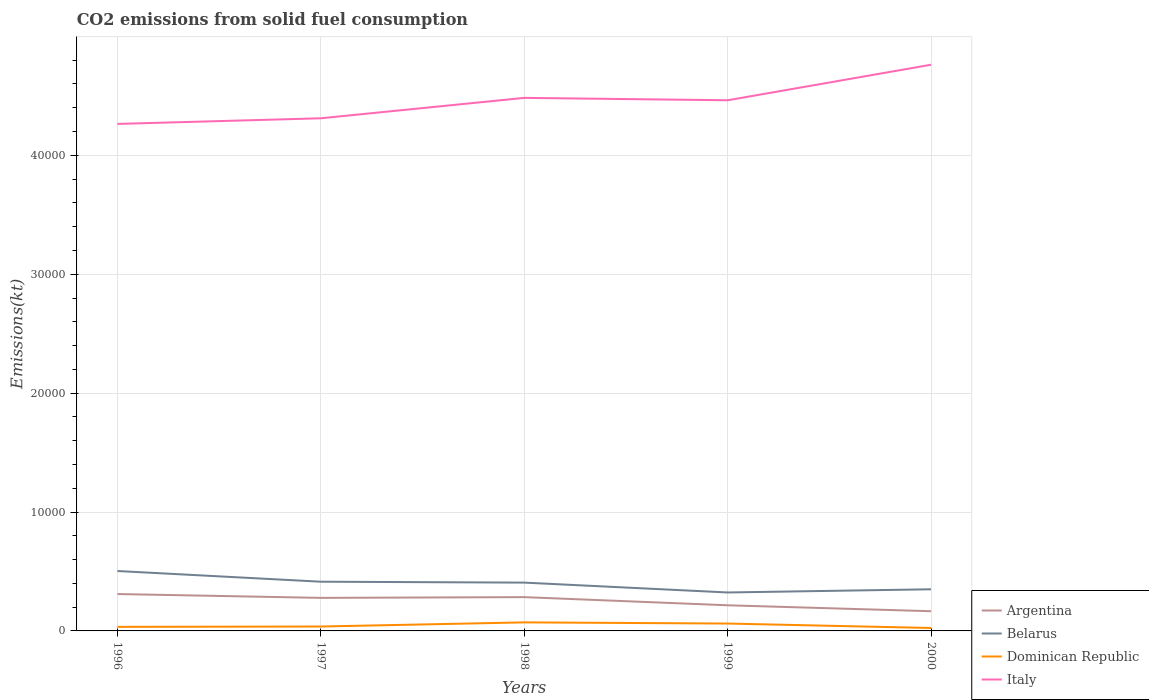Across all years, what is the maximum amount of CO2 emitted in Argentina?
Provide a succinct answer. 1657.48. What is the total amount of CO2 emitted in Belarus in the graph?
Offer a terse response. 898.41. What is the difference between the highest and the second highest amount of CO2 emitted in Dominican Republic?
Ensure brevity in your answer.  473.04. What is the difference between the highest and the lowest amount of CO2 emitted in Argentina?
Provide a short and direct response. 3. How many lines are there?
Provide a succinct answer. 4. How many years are there in the graph?
Make the answer very short. 5. Does the graph contain any zero values?
Your answer should be compact. No. How many legend labels are there?
Offer a very short reply. 4. How are the legend labels stacked?
Offer a terse response. Vertical. What is the title of the graph?
Offer a terse response. CO2 emissions from solid fuel consumption. What is the label or title of the Y-axis?
Provide a short and direct response. Emissions(kt). What is the Emissions(kt) of Argentina in 1996?
Give a very brief answer. 3102.28. What is the Emissions(kt) of Belarus in 1996?
Provide a short and direct response. 5038.46. What is the Emissions(kt) in Dominican Republic in 1996?
Give a very brief answer. 341.03. What is the Emissions(kt) of Italy in 1996?
Ensure brevity in your answer.  4.26e+04. What is the Emissions(kt) in Argentina in 1997?
Give a very brief answer. 2779.59. What is the Emissions(kt) in Belarus in 1997?
Provide a succinct answer. 4140.04. What is the Emissions(kt) of Dominican Republic in 1997?
Give a very brief answer. 370.37. What is the Emissions(kt) of Italy in 1997?
Ensure brevity in your answer.  4.31e+04. What is the Emissions(kt) of Argentina in 1998?
Your response must be concise. 2841.93. What is the Emissions(kt) of Belarus in 1998?
Your response must be concise. 4063.04. What is the Emissions(kt) in Dominican Republic in 1998?
Provide a short and direct response. 718.73. What is the Emissions(kt) in Italy in 1998?
Your answer should be compact. 4.48e+04. What is the Emissions(kt) in Argentina in 1999?
Make the answer very short. 2156.2. What is the Emissions(kt) of Belarus in 1999?
Provide a succinct answer. 3234.29. What is the Emissions(kt) of Dominican Republic in 1999?
Make the answer very short. 619.72. What is the Emissions(kt) in Italy in 1999?
Your response must be concise. 4.46e+04. What is the Emissions(kt) of Argentina in 2000?
Ensure brevity in your answer.  1657.48. What is the Emissions(kt) in Belarus in 2000?
Give a very brief answer. 3501.99. What is the Emissions(kt) of Dominican Republic in 2000?
Keep it short and to the point. 245.69. What is the Emissions(kt) of Italy in 2000?
Your response must be concise. 4.76e+04. Across all years, what is the maximum Emissions(kt) in Argentina?
Ensure brevity in your answer.  3102.28. Across all years, what is the maximum Emissions(kt) in Belarus?
Ensure brevity in your answer.  5038.46. Across all years, what is the maximum Emissions(kt) of Dominican Republic?
Ensure brevity in your answer.  718.73. Across all years, what is the maximum Emissions(kt) of Italy?
Your response must be concise. 4.76e+04. Across all years, what is the minimum Emissions(kt) in Argentina?
Make the answer very short. 1657.48. Across all years, what is the minimum Emissions(kt) in Belarus?
Ensure brevity in your answer.  3234.29. Across all years, what is the minimum Emissions(kt) in Dominican Republic?
Give a very brief answer. 245.69. Across all years, what is the minimum Emissions(kt) in Italy?
Your answer should be compact. 4.26e+04. What is the total Emissions(kt) in Argentina in the graph?
Provide a succinct answer. 1.25e+04. What is the total Emissions(kt) in Belarus in the graph?
Give a very brief answer. 2.00e+04. What is the total Emissions(kt) of Dominican Republic in the graph?
Keep it short and to the point. 2295.54. What is the total Emissions(kt) of Italy in the graph?
Give a very brief answer. 2.23e+05. What is the difference between the Emissions(kt) in Argentina in 1996 and that in 1997?
Give a very brief answer. 322.7. What is the difference between the Emissions(kt) of Belarus in 1996 and that in 1997?
Offer a terse response. 898.41. What is the difference between the Emissions(kt) of Dominican Republic in 1996 and that in 1997?
Ensure brevity in your answer.  -29.34. What is the difference between the Emissions(kt) of Italy in 1996 and that in 1997?
Your answer should be compact. -473.04. What is the difference between the Emissions(kt) in Argentina in 1996 and that in 1998?
Your answer should be compact. 260.36. What is the difference between the Emissions(kt) of Belarus in 1996 and that in 1998?
Provide a short and direct response. 975.42. What is the difference between the Emissions(kt) of Dominican Republic in 1996 and that in 1998?
Ensure brevity in your answer.  -377.7. What is the difference between the Emissions(kt) in Italy in 1996 and that in 1998?
Offer a terse response. -2189.2. What is the difference between the Emissions(kt) in Argentina in 1996 and that in 1999?
Give a very brief answer. 946.09. What is the difference between the Emissions(kt) of Belarus in 1996 and that in 1999?
Ensure brevity in your answer.  1804.16. What is the difference between the Emissions(kt) in Dominican Republic in 1996 and that in 1999?
Your answer should be very brief. -278.69. What is the difference between the Emissions(kt) in Italy in 1996 and that in 1999?
Make the answer very short. -1987.51. What is the difference between the Emissions(kt) in Argentina in 1996 and that in 2000?
Provide a short and direct response. 1444.8. What is the difference between the Emissions(kt) in Belarus in 1996 and that in 2000?
Offer a terse response. 1536.47. What is the difference between the Emissions(kt) of Dominican Republic in 1996 and that in 2000?
Ensure brevity in your answer.  95.34. What is the difference between the Emissions(kt) of Italy in 1996 and that in 2000?
Your response must be concise. -4976.12. What is the difference between the Emissions(kt) in Argentina in 1997 and that in 1998?
Your answer should be very brief. -62.34. What is the difference between the Emissions(kt) in Belarus in 1997 and that in 1998?
Make the answer very short. 77.01. What is the difference between the Emissions(kt) in Dominican Republic in 1997 and that in 1998?
Provide a short and direct response. -348.37. What is the difference between the Emissions(kt) of Italy in 1997 and that in 1998?
Give a very brief answer. -1716.16. What is the difference between the Emissions(kt) in Argentina in 1997 and that in 1999?
Provide a succinct answer. 623.39. What is the difference between the Emissions(kt) in Belarus in 1997 and that in 1999?
Make the answer very short. 905.75. What is the difference between the Emissions(kt) of Dominican Republic in 1997 and that in 1999?
Your response must be concise. -249.36. What is the difference between the Emissions(kt) of Italy in 1997 and that in 1999?
Provide a short and direct response. -1514.47. What is the difference between the Emissions(kt) of Argentina in 1997 and that in 2000?
Your answer should be very brief. 1122.1. What is the difference between the Emissions(kt) of Belarus in 1997 and that in 2000?
Your answer should be compact. 638.06. What is the difference between the Emissions(kt) of Dominican Republic in 1997 and that in 2000?
Make the answer very short. 124.68. What is the difference between the Emissions(kt) of Italy in 1997 and that in 2000?
Offer a terse response. -4503.08. What is the difference between the Emissions(kt) in Argentina in 1998 and that in 1999?
Keep it short and to the point. 685.73. What is the difference between the Emissions(kt) in Belarus in 1998 and that in 1999?
Give a very brief answer. 828.74. What is the difference between the Emissions(kt) in Dominican Republic in 1998 and that in 1999?
Give a very brief answer. 99.01. What is the difference between the Emissions(kt) in Italy in 1998 and that in 1999?
Ensure brevity in your answer.  201.69. What is the difference between the Emissions(kt) in Argentina in 1998 and that in 2000?
Offer a terse response. 1184.44. What is the difference between the Emissions(kt) of Belarus in 1998 and that in 2000?
Offer a terse response. 561.05. What is the difference between the Emissions(kt) of Dominican Republic in 1998 and that in 2000?
Your answer should be very brief. 473.04. What is the difference between the Emissions(kt) of Italy in 1998 and that in 2000?
Ensure brevity in your answer.  -2786.92. What is the difference between the Emissions(kt) of Argentina in 1999 and that in 2000?
Make the answer very short. 498.71. What is the difference between the Emissions(kt) of Belarus in 1999 and that in 2000?
Provide a succinct answer. -267.69. What is the difference between the Emissions(kt) of Dominican Republic in 1999 and that in 2000?
Offer a terse response. 374.03. What is the difference between the Emissions(kt) of Italy in 1999 and that in 2000?
Your answer should be compact. -2988.61. What is the difference between the Emissions(kt) of Argentina in 1996 and the Emissions(kt) of Belarus in 1997?
Keep it short and to the point. -1037.76. What is the difference between the Emissions(kt) of Argentina in 1996 and the Emissions(kt) of Dominican Republic in 1997?
Offer a very short reply. 2731.91. What is the difference between the Emissions(kt) in Argentina in 1996 and the Emissions(kt) in Italy in 1997?
Your response must be concise. -4.00e+04. What is the difference between the Emissions(kt) of Belarus in 1996 and the Emissions(kt) of Dominican Republic in 1997?
Give a very brief answer. 4668.09. What is the difference between the Emissions(kt) in Belarus in 1996 and the Emissions(kt) in Italy in 1997?
Your answer should be very brief. -3.81e+04. What is the difference between the Emissions(kt) in Dominican Republic in 1996 and the Emissions(kt) in Italy in 1997?
Keep it short and to the point. -4.28e+04. What is the difference between the Emissions(kt) in Argentina in 1996 and the Emissions(kt) in Belarus in 1998?
Offer a terse response. -960.75. What is the difference between the Emissions(kt) of Argentina in 1996 and the Emissions(kt) of Dominican Republic in 1998?
Your answer should be very brief. 2383.55. What is the difference between the Emissions(kt) in Argentina in 1996 and the Emissions(kt) in Italy in 1998?
Your answer should be compact. -4.17e+04. What is the difference between the Emissions(kt) of Belarus in 1996 and the Emissions(kt) of Dominican Republic in 1998?
Ensure brevity in your answer.  4319.73. What is the difference between the Emissions(kt) in Belarus in 1996 and the Emissions(kt) in Italy in 1998?
Offer a terse response. -3.98e+04. What is the difference between the Emissions(kt) in Dominican Republic in 1996 and the Emissions(kt) in Italy in 1998?
Your answer should be very brief. -4.45e+04. What is the difference between the Emissions(kt) of Argentina in 1996 and the Emissions(kt) of Belarus in 1999?
Keep it short and to the point. -132.01. What is the difference between the Emissions(kt) in Argentina in 1996 and the Emissions(kt) in Dominican Republic in 1999?
Provide a short and direct response. 2482.56. What is the difference between the Emissions(kt) in Argentina in 1996 and the Emissions(kt) in Italy in 1999?
Keep it short and to the point. -4.15e+04. What is the difference between the Emissions(kt) of Belarus in 1996 and the Emissions(kt) of Dominican Republic in 1999?
Your response must be concise. 4418.73. What is the difference between the Emissions(kt) in Belarus in 1996 and the Emissions(kt) in Italy in 1999?
Make the answer very short. -3.96e+04. What is the difference between the Emissions(kt) of Dominican Republic in 1996 and the Emissions(kt) of Italy in 1999?
Make the answer very short. -4.43e+04. What is the difference between the Emissions(kt) of Argentina in 1996 and the Emissions(kt) of Belarus in 2000?
Make the answer very short. -399.7. What is the difference between the Emissions(kt) of Argentina in 1996 and the Emissions(kt) of Dominican Republic in 2000?
Offer a very short reply. 2856.59. What is the difference between the Emissions(kt) in Argentina in 1996 and the Emissions(kt) in Italy in 2000?
Keep it short and to the point. -4.45e+04. What is the difference between the Emissions(kt) in Belarus in 1996 and the Emissions(kt) in Dominican Republic in 2000?
Give a very brief answer. 4792.77. What is the difference between the Emissions(kt) of Belarus in 1996 and the Emissions(kt) of Italy in 2000?
Ensure brevity in your answer.  -4.26e+04. What is the difference between the Emissions(kt) of Dominican Republic in 1996 and the Emissions(kt) of Italy in 2000?
Provide a succinct answer. -4.73e+04. What is the difference between the Emissions(kt) in Argentina in 1997 and the Emissions(kt) in Belarus in 1998?
Give a very brief answer. -1283.45. What is the difference between the Emissions(kt) in Argentina in 1997 and the Emissions(kt) in Dominican Republic in 1998?
Give a very brief answer. 2060.85. What is the difference between the Emissions(kt) in Argentina in 1997 and the Emissions(kt) in Italy in 1998?
Offer a very short reply. -4.21e+04. What is the difference between the Emissions(kt) in Belarus in 1997 and the Emissions(kt) in Dominican Republic in 1998?
Your answer should be very brief. 3421.31. What is the difference between the Emissions(kt) of Belarus in 1997 and the Emissions(kt) of Italy in 1998?
Provide a succinct answer. -4.07e+04. What is the difference between the Emissions(kt) in Dominican Republic in 1997 and the Emissions(kt) in Italy in 1998?
Your response must be concise. -4.45e+04. What is the difference between the Emissions(kt) of Argentina in 1997 and the Emissions(kt) of Belarus in 1999?
Your answer should be very brief. -454.71. What is the difference between the Emissions(kt) in Argentina in 1997 and the Emissions(kt) in Dominican Republic in 1999?
Your answer should be compact. 2159.86. What is the difference between the Emissions(kt) in Argentina in 1997 and the Emissions(kt) in Italy in 1999?
Ensure brevity in your answer.  -4.19e+04. What is the difference between the Emissions(kt) in Belarus in 1997 and the Emissions(kt) in Dominican Republic in 1999?
Your response must be concise. 3520.32. What is the difference between the Emissions(kt) in Belarus in 1997 and the Emissions(kt) in Italy in 1999?
Keep it short and to the point. -4.05e+04. What is the difference between the Emissions(kt) in Dominican Republic in 1997 and the Emissions(kt) in Italy in 1999?
Your answer should be very brief. -4.43e+04. What is the difference between the Emissions(kt) in Argentina in 1997 and the Emissions(kt) in Belarus in 2000?
Keep it short and to the point. -722.4. What is the difference between the Emissions(kt) of Argentina in 1997 and the Emissions(kt) of Dominican Republic in 2000?
Your answer should be very brief. 2533.9. What is the difference between the Emissions(kt) of Argentina in 1997 and the Emissions(kt) of Italy in 2000?
Your answer should be very brief. -4.48e+04. What is the difference between the Emissions(kt) in Belarus in 1997 and the Emissions(kt) in Dominican Republic in 2000?
Your answer should be very brief. 3894.35. What is the difference between the Emissions(kt) in Belarus in 1997 and the Emissions(kt) in Italy in 2000?
Your answer should be compact. -4.35e+04. What is the difference between the Emissions(kt) in Dominican Republic in 1997 and the Emissions(kt) in Italy in 2000?
Your answer should be compact. -4.72e+04. What is the difference between the Emissions(kt) in Argentina in 1998 and the Emissions(kt) in Belarus in 1999?
Offer a terse response. -392.37. What is the difference between the Emissions(kt) of Argentina in 1998 and the Emissions(kt) of Dominican Republic in 1999?
Offer a terse response. 2222.2. What is the difference between the Emissions(kt) in Argentina in 1998 and the Emissions(kt) in Italy in 1999?
Offer a terse response. -4.18e+04. What is the difference between the Emissions(kt) in Belarus in 1998 and the Emissions(kt) in Dominican Republic in 1999?
Give a very brief answer. 3443.31. What is the difference between the Emissions(kt) of Belarus in 1998 and the Emissions(kt) of Italy in 1999?
Ensure brevity in your answer.  -4.06e+04. What is the difference between the Emissions(kt) of Dominican Republic in 1998 and the Emissions(kt) of Italy in 1999?
Offer a terse response. -4.39e+04. What is the difference between the Emissions(kt) in Argentina in 1998 and the Emissions(kt) in Belarus in 2000?
Provide a short and direct response. -660.06. What is the difference between the Emissions(kt) of Argentina in 1998 and the Emissions(kt) of Dominican Republic in 2000?
Give a very brief answer. 2596.24. What is the difference between the Emissions(kt) of Argentina in 1998 and the Emissions(kt) of Italy in 2000?
Give a very brief answer. -4.48e+04. What is the difference between the Emissions(kt) in Belarus in 1998 and the Emissions(kt) in Dominican Republic in 2000?
Your response must be concise. 3817.35. What is the difference between the Emissions(kt) in Belarus in 1998 and the Emissions(kt) in Italy in 2000?
Ensure brevity in your answer.  -4.36e+04. What is the difference between the Emissions(kt) of Dominican Republic in 1998 and the Emissions(kt) of Italy in 2000?
Offer a very short reply. -4.69e+04. What is the difference between the Emissions(kt) in Argentina in 1999 and the Emissions(kt) in Belarus in 2000?
Provide a short and direct response. -1345.79. What is the difference between the Emissions(kt) in Argentina in 1999 and the Emissions(kt) in Dominican Republic in 2000?
Your response must be concise. 1910.51. What is the difference between the Emissions(kt) in Argentina in 1999 and the Emissions(kt) in Italy in 2000?
Ensure brevity in your answer.  -4.55e+04. What is the difference between the Emissions(kt) in Belarus in 1999 and the Emissions(kt) in Dominican Republic in 2000?
Give a very brief answer. 2988.61. What is the difference between the Emissions(kt) in Belarus in 1999 and the Emissions(kt) in Italy in 2000?
Offer a very short reply. -4.44e+04. What is the difference between the Emissions(kt) of Dominican Republic in 1999 and the Emissions(kt) of Italy in 2000?
Keep it short and to the point. -4.70e+04. What is the average Emissions(kt) of Argentina per year?
Ensure brevity in your answer.  2507.49. What is the average Emissions(kt) of Belarus per year?
Offer a very short reply. 3995.56. What is the average Emissions(kt) in Dominican Republic per year?
Provide a short and direct response. 459.11. What is the average Emissions(kt) in Italy per year?
Keep it short and to the point. 4.46e+04. In the year 1996, what is the difference between the Emissions(kt) in Argentina and Emissions(kt) in Belarus?
Your answer should be compact. -1936.18. In the year 1996, what is the difference between the Emissions(kt) of Argentina and Emissions(kt) of Dominican Republic?
Your answer should be very brief. 2761.25. In the year 1996, what is the difference between the Emissions(kt) in Argentina and Emissions(kt) in Italy?
Offer a terse response. -3.95e+04. In the year 1996, what is the difference between the Emissions(kt) in Belarus and Emissions(kt) in Dominican Republic?
Provide a succinct answer. 4697.43. In the year 1996, what is the difference between the Emissions(kt) in Belarus and Emissions(kt) in Italy?
Your response must be concise. -3.76e+04. In the year 1996, what is the difference between the Emissions(kt) of Dominican Republic and Emissions(kt) of Italy?
Your answer should be compact. -4.23e+04. In the year 1997, what is the difference between the Emissions(kt) of Argentina and Emissions(kt) of Belarus?
Offer a terse response. -1360.46. In the year 1997, what is the difference between the Emissions(kt) of Argentina and Emissions(kt) of Dominican Republic?
Your response must be concise. 2409.22. In the year 1997, what is the difference between the Emissions(kt) of Argentina and Emissions(kt) of Italy?
Provide a short and direct response. -4.03e+04. In the year 1997, what is the difference between the Emissions(kt) of Belarus and Emissions(kt) of Dominican Republic?
Keep it short and to the point. 3769.68. In the year 1997, what is the difference between the Emissions(kt) in Belarus and Emissions(kt) in Italy?
Provide a succinct answer. -3.90e+04. In the year 1997, what is the difference between the Emissions(kt) in Dominican Republic and Emissions(kt) in Italy?
Keep it short and to the point. -4.27e+04. In the year 1998, what is the difference between the Emissions(kt) of Argentina and Emissions(kt) of Belarus?
Offer a terse response. -1221.11. In the year 1998, what is the difference between the Emissions(kt) in Argentina and Emissions(kt) in Dominican Republic?
Offer a terse response. 2123.19. In the year 1998, what is the difference between the Emissions(kt) in Argentina and Emissions(kt) in Italy?
Give a very brief answer. -4.20e+04. In the year 1998, what is the difference between the Emissions(kt) of Belarus and Emissions(kt) of Dominican Republic?
Provide a short and direct response. 3344.3. In the year 1998, what is the difference between the Emissions(kt) of Belarus and Emissions(kt) of Italy?
Ensure brevity in your answer.  -4.08e+04. In the year 1998, what is the difference between the Emissions(kt) of Dominican Republic and Emissions(kt) of Italy?
Your answer should be very brief. -4.41e+04. In the year 1999, what is the difference between the Emissions(kt) of Argentina and Emissions(kt) of Belarus?
Your response must be concise. -1078.1. In the year 1999, what is the difference between the Emissions(kt) of Argentina and Emissions(kt) of Dominican Republic?
Your answer should be very brief. 1536.47. In the year 1999, what is the difference between the Emissions(kt) in Argentina and Emissions(kt) in Italy?
Offer a terse response. -4.25e+04. In the year 1999, what is the difference between the Emissions(kt) in Belarus and Emissions(kt) in Dominican Republic?
Give a very brief answer. 2614.57. In the year 1999, what is the difference between the Emissions(kt) in Belarus and Emissions(kt) in Italy?
Offer a terse response. -4.14e+04. In the year 1999, what is the difference between the Emissions(kt) of Dominican Republic and Emissions(kt) of Italy?
Offer a very short reply. -4.40e+04. In the year 2000, what is the difference between the Emissions(kt) in Argentina and Emissions(kt) in Belarus?
Ensure brevity in your answer.  -1844.5. In the year 2000, what is the difference between the Emissions(kt) in Argentina and Emissions(kt) in Dominican Republic?
Offer a very short reply. 1411.8. In the year 2000, what is the difference between the Emissions(kt) of Argentina and Emissions(kt) of Italy?
Make the answer very short. -4.60e+04. In the year 2000, what is the difference between the Emissions(kt) of Belarus and Emissions(kt) of Dominican Republic?
Keep it short and to the point. 3256.3. In the year 2000, what is the difference between the Emissions(kt) of Belarus and Emissions(kt) of Italy?
Give a very brief answer. -4.41e+04. In the year 2000, what is the difference between the Emissions(kt) of Dominican Republic and Emissions(kt) of Italy?
Offer a very short reply. -4.74e+04. What is the ratio of the Emissions(kt) in Argentina in 1996 to that in 1997?
Provide a short and direct response. 1.12. What is the ratio of the Emissions(kt) of Belarus in 1996 to that in 1997?
Your answer should be very brief. 1.22. What is the ratio of the Emissions(kt) of Dominican Republic in 1996 to that in 1997?
Ensure brevity in your answer.  0.92. What is the ratio of the Emissions(kt) in Argentina in 1996 to that in 1998?
Ensure brevity in your answer.  1.09. What is the ratio of the Emissions(kt) in Belarus in 1996 to that in 1998?
Ensure brevity in your answer.  1.24. What is the ratio of the Emissions(kt) in Dominican Republic in 1996 to that in 1998?
Give a very brief answer. 0.47. What is the ratio of the Emissions(kt) in Italy in 1996 to that in 1998?
Provide a short and direct response. 0.95. What is the ratio of the Emissions(kt) in Argentina in 1996 to that in 1999?
Your answer should be compact. 1.44. What is the ratio of the Emissions(kt) of Belarus in 1996 to that in 1999?
Your response must be concise. 1.56. What is the ratio of the Emissions(kt) of Dominican Republic in 1996 to that in 1999?
Provide a short and direct response. 0.55. What is the ratio of the Emissions(kt) in Italy in 1996 to that in 1999?
Provide a short and direct response. 0.96. What is the ratio of the Emissions(kt) of Argentina in 1996 to that in 2000?
Provide a short and direct response. 1.87. What is the ratio of the Emissions(kt) in Belarus in 1996 to that in 2000?
Ensure brevity in your answer.  1.44. What is the ratio of the Emissions(kt) of Dominican Republic in 1996 to that in 2000?
Your answer should be very brief. 1.39. What is the ratio of the Emissions(kt) in Italy in 1996 to that in 2000?
Your answer should be very brief. 0.9. What is the ratio of the Emissions(kt) of Argentina in 1997 to that in 1998?
Give a very brief answer. 0.98. What is the ratio of the Emissions(kt) of Belarus in 1997 to that in 1998?
Offer a terse response. 1.02. What is the ratio of the Emissions(kt) of Dominican Republic in 1997 to that in 1998?
Provide a short and direct response. 0.52. What is the ratio of the Emissions(kt) in Italy in 1997 to that in 1998?
Your answer should be compact. 0.96. What is the ratio of the Emissions(kt) of Argentina in 1997 to that in 1999?
Ensure brevity in your answer.  1.29. What is the ratio of the Emissions(kt) in Belarus in 1997 to that in 1999?
Offer a very short reply. 1.28. What is the ratio of the Emissions(kt) in Dominican Republic in 1997 to that in 1999?
Provide a succinct answer. 0.6. What is the ratio of the Emissions(kt) in Italy in 1997 to that in 1999?
Provide a succinct answer. 0.97. What is the ratio of the Emissions(kt) of Argentina in 1997 to that in 2000?
Provide a succinct answer. 1.68. What is the ratio of the Emissions(kt) in Belarus in 1997 to that in 2000?
Provide a short and direct response. 1.18. What is the ratio of the Emissions(kt) of Dominican Republic in 1997 to that in 2000?
Offer a terse response. 1.51. What is the ratio of the Emissions(kt) of Italy in 1997 to that in 2000?
Provide a short and direct response. 0.91. What is the ratio of the Emissions(kt) of Argentina in 1998 to that in 1999?
Offer a very short reply. 1.32. What is the ratio of the Emissions(kt) in Belarus in 1998 to that in 1999?
Make the answer very short. 1.26. What is the ratio of the Emissions(kt) of Dominican Republic in 1998 to that in 1999?
Make the answer very short. 1.16. What is the ratio of the Emissions(kt) in Italy in 1998 to that in 1999?
Your answer should be very brief. 1. What is the ratio of the Emissions(kt) in Argentina in 1998 to that in 2000?
Provide a succinct answer. 1.71. What is the ratio of the Emissions(kt) in Belarus in 1998 to that in 2000?
Offer a very short reply. 1.16. What is the ratio of the Emissions(kt) in Dominican Republic in 1998 to that in 2000?
Offer a very short reply. 2.93. What is the ratio of the Emissions(kt) in Italy in 1998 to that in 2000?
Provide a succinct answer. 0.94. What is the ratio of the Emissions(kt) of Argentina in 1999 to that in 2000?
Provide a succinct answer. 1.3. What is the ratio of the Emissions(kt) of Belarus in 1999 to that in 2000?
Your answer should be compact. 0.92. What is the ratio of the Emissions(kt) in Dominican Republic in 1999 to that in 2000?
Provide a succinct answer. 2.52. What is the ratio of the Emissions(kt) in Italy in 1999 to that in 2000?
Offer a very short reply. 0.94. What is the difference between the highest and the second highest Emissions(kt) of Argentina?
Ensure brevity in your answer.  260.36. What is the difference between the highest and the second highest Emissions(kt) in Belarus?
Make the answer very short. 898.41. What is the difference between the highest and the second highest Emissions(kt) of Dominican Republic?
Provide a succinct answer. 99.01. What is the difference between the highest and the second highest Emissions(kt) of Italy?
Offer a very short reply. 2786.92. What is the difference between the highest and the lowest Emissions(kt) in Argentina?
Provide a succinct answer. 1444.8. What is the difference between the highest and the lowest Emissions(kt) of Belarus?
Provide a short and direct response. 1804.16. What is the difference between the highest and the lowest Emissions(kt) in Dominican Republic?
Your answer should be compact. 473.04. What is the difference between the highest and the lowest Emissions(kt) of Italy?
Give a very brief answer. 4976.12. 